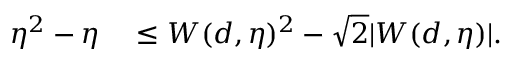Convert formula to latex. <formula><loc_0><loc_0><loc_500><loc_500>\begin{array} { r l } { \eta ^ { 2 } - \eta } & \leq W ( d , \eta ) ^ { 2 } - \sqrt { 2 } | W ( d , \eta ) | . } \end{array}</formula> 